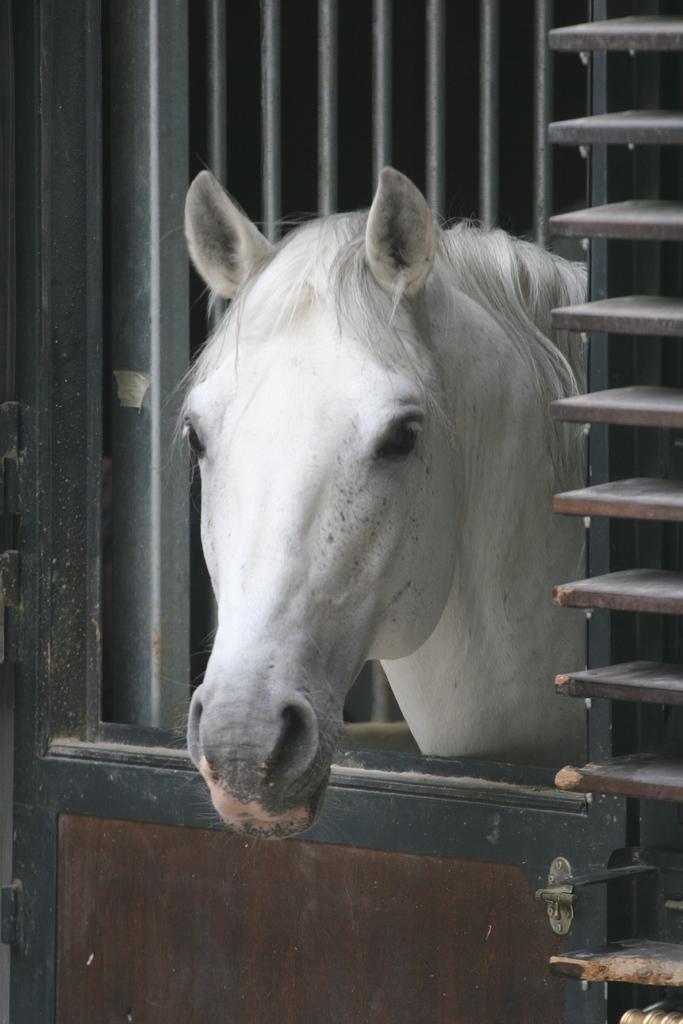Describe this image in one or two sentences. In this image I can see a window and I can see a horse head visible visible in the window. 